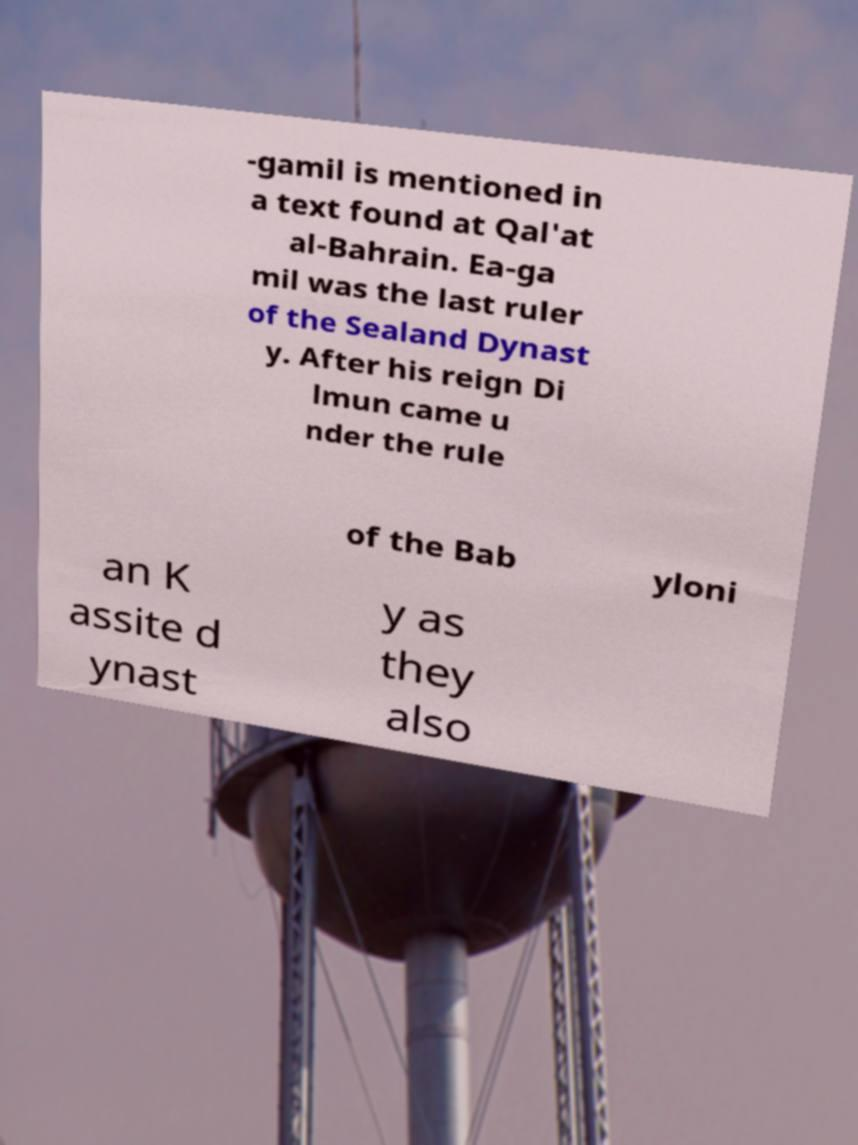Please identify and transcribe the text found in this image. -gamil is mentioned in a text found at Qal'at al-Bahrain. Ea-ga mil was the last ruler of the Sealand Dynast y. After his reign Di lmun came u nder the rule of the Bab yloni an K assite d ynast y as they also 